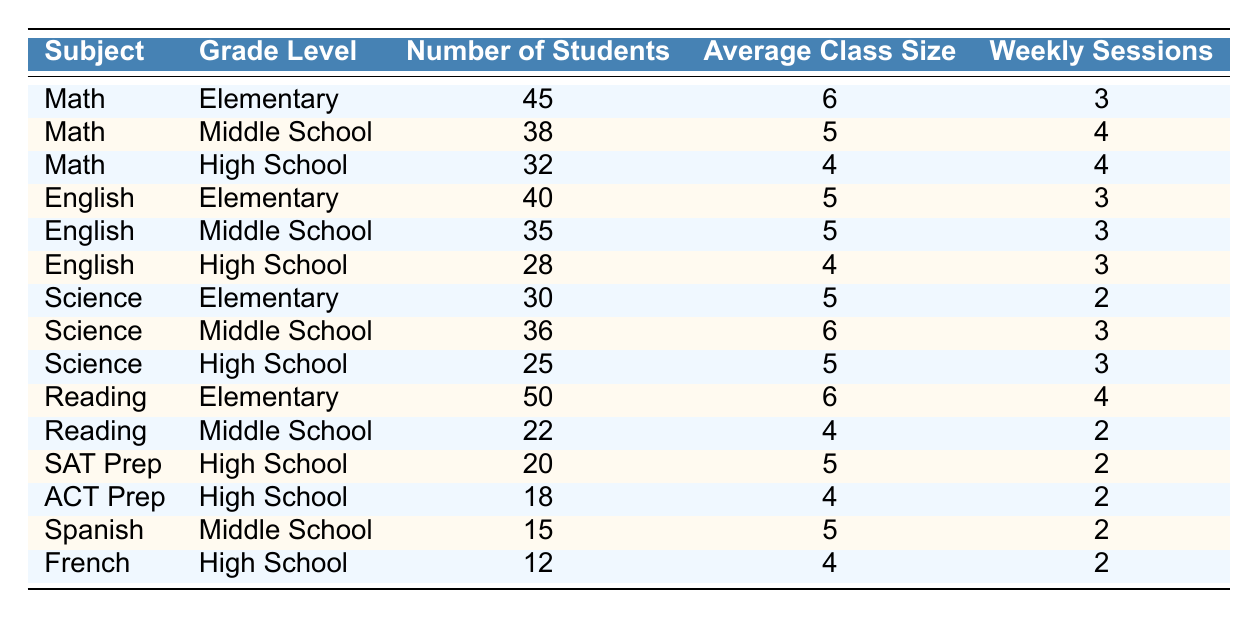What is the subject with the highest number of students in Elementary grade level? From the table, we can look at the number of students in the Elementary grade level for each subject. Math has 45 students, English has 40, Science has 30, and Reading has 50 students. The highest is Reading with 50 students.
Answer: Reading How many students are enrolled in High School Science? Referring to the High School row under Science, it shows that there are 25 students enrolled.
Answer: 25 What is the average class size for Middle School Math? Looking at the table, the average class size for Middle School Math is recorded as 5.
Answer: 5 Is there more than one subject with an average class size of 4 in High School? We can check the average class sizes for High School subjects in the table: Math has 4, English has 4, and Science has 5. Since both Math and English have an average class size of 4, the answer is yes.
Answer: Yes What is the total number of students enrolled across all subjects in Middle School? To find the total, we will sum the number of students for each Middle School subject: Math (38) + English (35) + Science (36) + Reading (22) + Spanish (15) = 146.
Answer: 146 What is the difference in the number of students between Elementary Reading and High School ACT Prep? For Elementary Reading, there are 50 students, and for High School ACT Prep, there are 18 students. The difference is 50 - 18 = 32.
Answer: 32 Which subject in High School has the least number of enrolled students? Checking the High School subjects, we see SAT Prep with 20 students, ACT Prep with 18 students, and French with 12 students. The least is French with 12 students.
Answer: French What is the average number of students enrolled in Elementary subjects? To find the average of Elementary students, we add them: Math (45) + English (40) + Science (30) + Reading (50) = 165, and divide by the number of subjects (4). So, the average is 165 / 4 = 41.25.
Answer: 41.25 How many weekly sessions does Middle School English have compared to High School English? The Middle School English has 3 weekly sessions, while High School English also has 3. Since they are equal, there is no difference.
Answer: 0 What is the total average class size for all subjects in High School? The average class sizes for High School subjects are: Math (4), English (4), Science (5), SAT Prep (5), ACT Prep (4), and French (4). Summing these gives 4 + 4 + 5 + 5 + 4 + 4 = 26. Divide by 6 (the number of subjects) gives an average of 26 / 6 = 4.33.
Answer: 4.33 